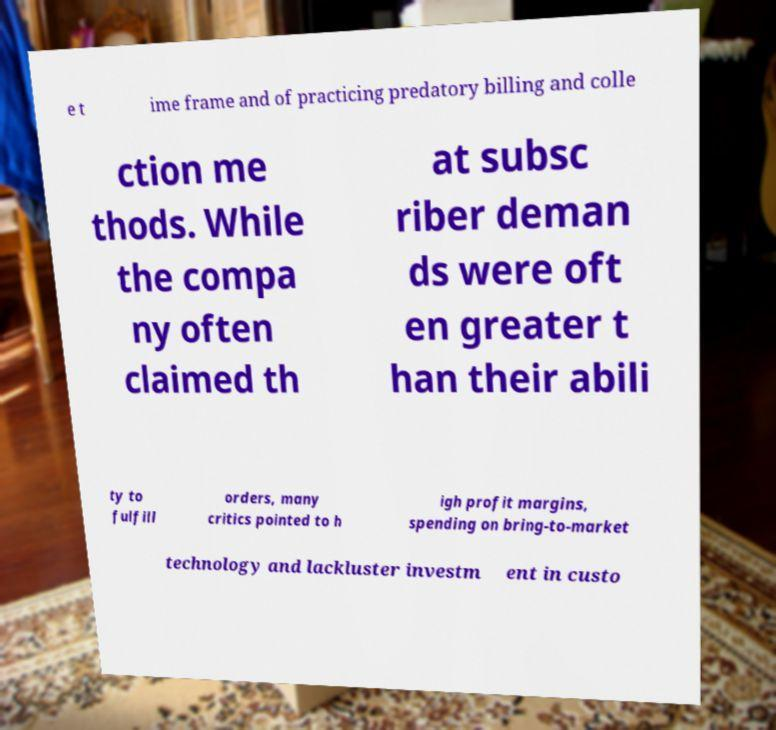There's text embedded in this image that I need extracted. Can you transcribe it verbatim? e t ime frame and of practicing predatory billing and colle ction me thods. While the compa ny often claimed th at subsc riber deman ds were oft en greater t han their abili ty to fulfill orders, many critics pointed to h igh profit margins, spending on bring-to-market technology and lackluster investm ent in custo 